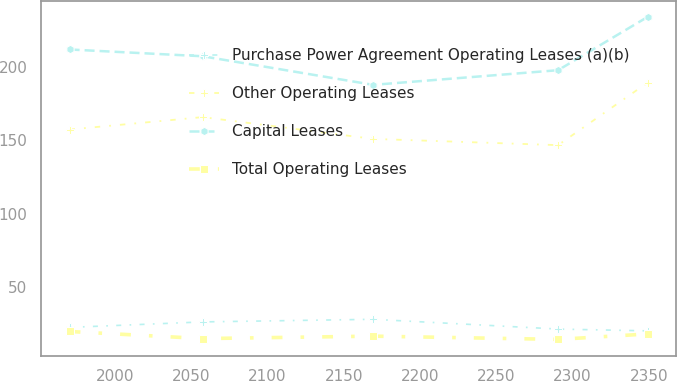<chart> <loc_0><loc_0><loc_500><loc_500><line_chart><ecel><fcel>Purchase Power Agreement Operating Leases (a)(b)<fcel>Other Operating Leases<fcel>Capital Leases<fcel>Total Operating Leases<nl><fcel>1970.37<fcel>22.43<fcel>157.39<fcel>211.99<fcel>19.63<nl><fcel>2057.59<fcel>26.17<fcel>165.86<fcel>207.36<fcel>14.8<nl><fcel>2169.32<fcel>27.95<fcel>151<fcel>187.86<fcel>16.46<nl><fcel>2290.51<fcel>21.29<fcel>146.74<fcel>197.85<fcel>14.25<nl><fcel>2349.12<fcel>20.07<fcel>189.35<fcel>234.15<fcel>17.95<nl></chart> 